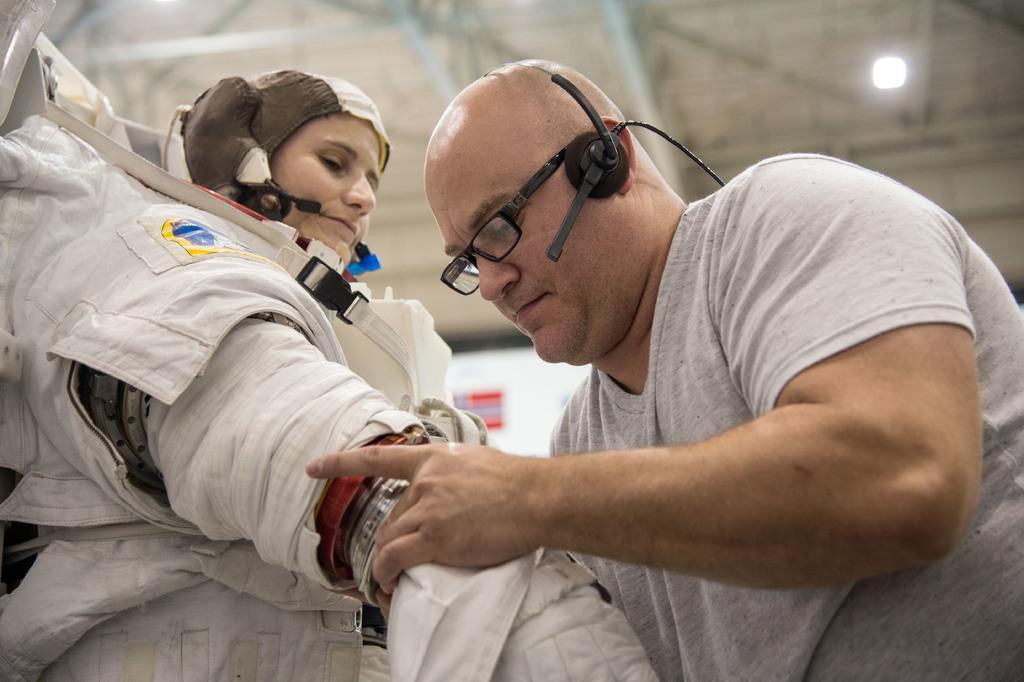In one or two sentences, can you explain what this image depicts? On the left side, there is a person in white color dress, wearing a mic and standing. On the right side, there is a person in gray color t-shirt, wearing a spectacle and a mic, standing and holding hand of a person who is opposite to him. In the background, there is a light attached to the roof. 